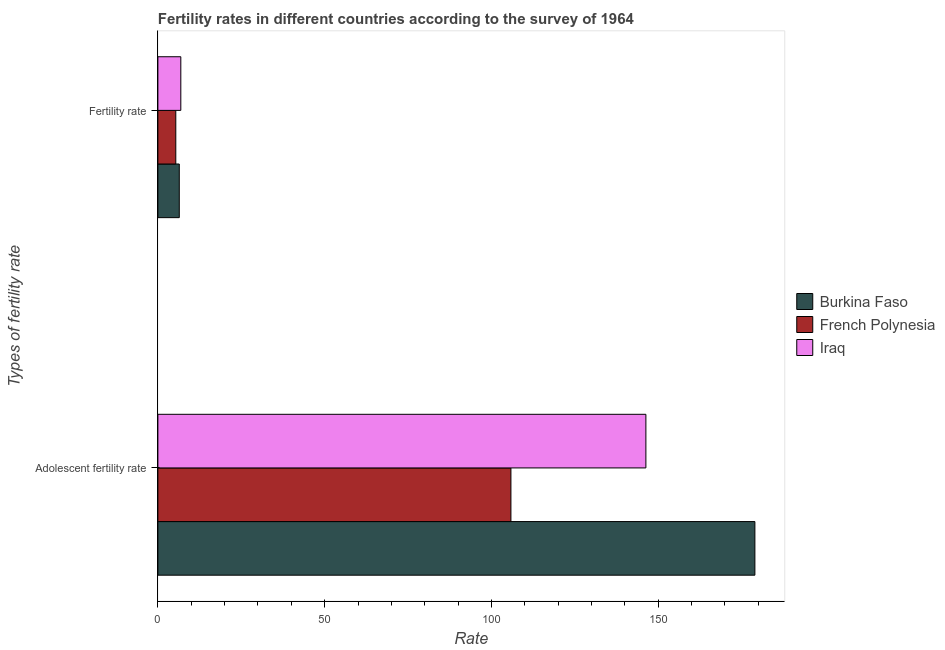How many groups of bars are there?
Give a very brief answer. 2. Are the number of bars per tick equal to the number of legend labels?
Your answer should be very brief. Yes. Are the number of bars on each tick of the Y-axis equal?
Keep it short and to the point. Yes. What is the label of the 2nd group of bars from the top?
Offer a terse response. Adolescent fertility rate. What is the fertility rate in French Polynesia?
Your response must be concise. 5.37. Across all countries, what is the maximum fertility rate?
Your answer should be very brief. 6.87. Across all countries, what is the minimum fertility rate?
Give a very brief answer. 5.37. In which country was the adolescent fertility rate maximum?
Give a very brief answer. Burkina Faso. In which country was the adolescent fertility rate minimum?
Offer a very short reply. French Polynesia. What is the total adolescent fertility rate in the graph?
Make the answer very short. 431.14. What is the difference between the adolescent fertility rate in Iraq and that in Burkina Faso?
Offer a terse response. -32.68. What is the difference between the fertility rate in Iraq and the adolescent fertility rate in Burkina Faso?
Offer a very short reply. -172.11. What is the average adolescent fertility rate per country?
Provide a short and direct response. 143.71. What is the difference between the adolescent fertility rate and fertility rate in Burkina Faso?
Make the answer very short. 172.57. In how many countries, is the fertility rate greater than 160 ?
Offer a terse response. 0. What is the ratio of the fertility rate in Iraq to that in French Polynesia?
Provide a succinct answer. 1.28. What does the 3rd bar from the top in Fertility rate represents?
Make the answer very short. Burkina Faso. What does the 3rd bar from the bottom in Fertility rate represents?
Offer a terse response. Iraq. How many bars are there?
Your answer should be compact. 6. How many countries are there in the graph?
Ensure brevity in your answer.  3. What is the difference between two consecutive major ticks on the X-axis?
Offer a terse response. 50. How many legend labels are there?
Your response must be concise. 3. What is the title of the graph?
Your answer should be compact. Fertility rates in different countries according to the survey of 1964. Does "Angola" appear as one of the legend labels in the graph?
Your answer should be very brief. No. What is the label or title of the X-axis?
Offer a terse response. Rate. What is the label or title of the Y-axis?
Offer a very short reply. Types of fertility rate. What is the Rate of Burkina Faso in Adolescent fertility rate?
Your answer should be very brief. 178.99. What is the Rate in French Polynesia in Adolescent fertility rate?
Your answer should be very brief. 105.84. What is the Rate of Iraq in Adolescent fertility rate?
Offer a very short reply. 146.31. What is the Rate of Burkina Faso in Fertility rate?
Your answer should be very brief. 6.41. What is the Rate of French Polynesia in Fertility rate?
Your answer should be compact. 5.37. What is the Rate of Iraq in Fertility rate?
Give a very brief answer. 6.87. Across all Types of fertility rate, what is the maximum Rate in Burkina Faso?
Provide a succinct answer. 178.99. Across all Types of fertility rate, what is the maximum Rate in French Polynesia?
Your response must be concise. 105.84. Across all Types of fertility rate, what is the maximum Rate of Iraq?
Provide a succinct answer. 146.31. Across all Types of fertility rate, what is the minimum Rate of Burkina Faso?
Provide a succinct answer. 6.41. Across all Types of fertility rate, what is the minimum Rate of French Polynesia?
Provide a short and direct response. 5.37. Across all Types of fertility rate, what is the minimum Rate of Iraq?
Your answer should be very brief. 6.87. What is the total Rate of Burkina Faso in the graph?
Offer a terse response. 185.4. What is the total Rate of French Polynesia in the graph?
Provide a succinct answer. 111.21. What is the total Rate of Iraq in the graph?
Your response must be concise. 153.18. What is the difference between the Rate of Burkina Faso in Adolescent fertility rate and that in Fertility rate?
Ensure brevity in your answer.  172.57. What is the difference between the Rate of French Polynesia in Adolescent fertility rate and that in Fertility rate?
Your response must be concise. 100.48. What is the difference between the Rate in Iraq in Adolescent fertility rate and that in Fertility rate?
Provide a succinct answer. 139.44. What is the difference between the Rate in Burkina Faso in Adolescent fertility rate and the Rate in French Polynesia in Fertility rate?
Offer a very short reply. 173.62. What is the difference between the Rate in Burkina Faso in Adolescent fertility rate and the Rate in Iraq in Fertility rate?
Offer a terse response. 172.12. What is the difference between the Rate in French Polynesia in Adolescent fertility rate and the Rate in Iraq in Fertility rate?
Make the answer very short. 98.97. What is the average Rate in Burkina Faso per Types of fertility rate?
Your response must be concise. 92.7. What is the average Rate of French Polynesia per Types of fertility rate?
Offer a very short reply. 55.61. What is the average Rate in Iraq per Types of fertility rate?
Provide a short and direct response. 76.59. What is the difference between the Rate in Burkina Faso and Rate in French Polynesia in Adolescent fertility rate?
Give a very brief answer. 73.14. What is the difference between the Rate of Burkina Faso and Rate of Iraq in Adolescent fertility rate?
Your response must be concise. 32.68. What is the difference between the Rate of French Polynesia and Rate of Iraq in Adolescent fertility rate?
Your response must be concise. -40.46. What is the difference between the Rate in Burkina Faso and Rate in French Polynesia in Fertility rate?
Keep it short and to the point. 1.05. What is the difference between the Rate of Burkina Faso and Rate of Iraq in Fertility rate?
Make the answer very short. -0.46. What is the difference between the Rate in French Polynesia and Rate in Iraq in Fertility rate?
Give a very brief answer. -1.5. What is the ratio of the Rate in Burkina Faso in Adolescent fertility rate to that in Fertility rate?
Make the answer very short. 27.91. What is the ratio of the Rate of French Polynesia in Adolescent fertility rate to that in Fertility rate?
Your answer should be very brief. 19.72. What is the ratio of the Rate in Iraq in Adolescent fertility rate to that in Fertility rate?
Give a very brief answer. 21.29. What is the difference between the highest and the second highest Rate in Burkina Faso?
Your answer should be very brief. 172.57. What is the difference between the highest and the second highest Rate of French Polynesia?
Your answer should be very brief. 100.48. What is the difference between the highest and the second highest Rate in Iraq?
Your answer should be compact. 139.44. What is the difference between the highest and the lowest Rate of Burkina Faso?
Offer a very short reply. 172.57. What is the difference between the highest and the lowest Rate of French Polynesia?
Make the answer very short. 100.48. What is the difference between the highest and the lowest Rate in Iraq?
Offer a very short reply. 139.44. 